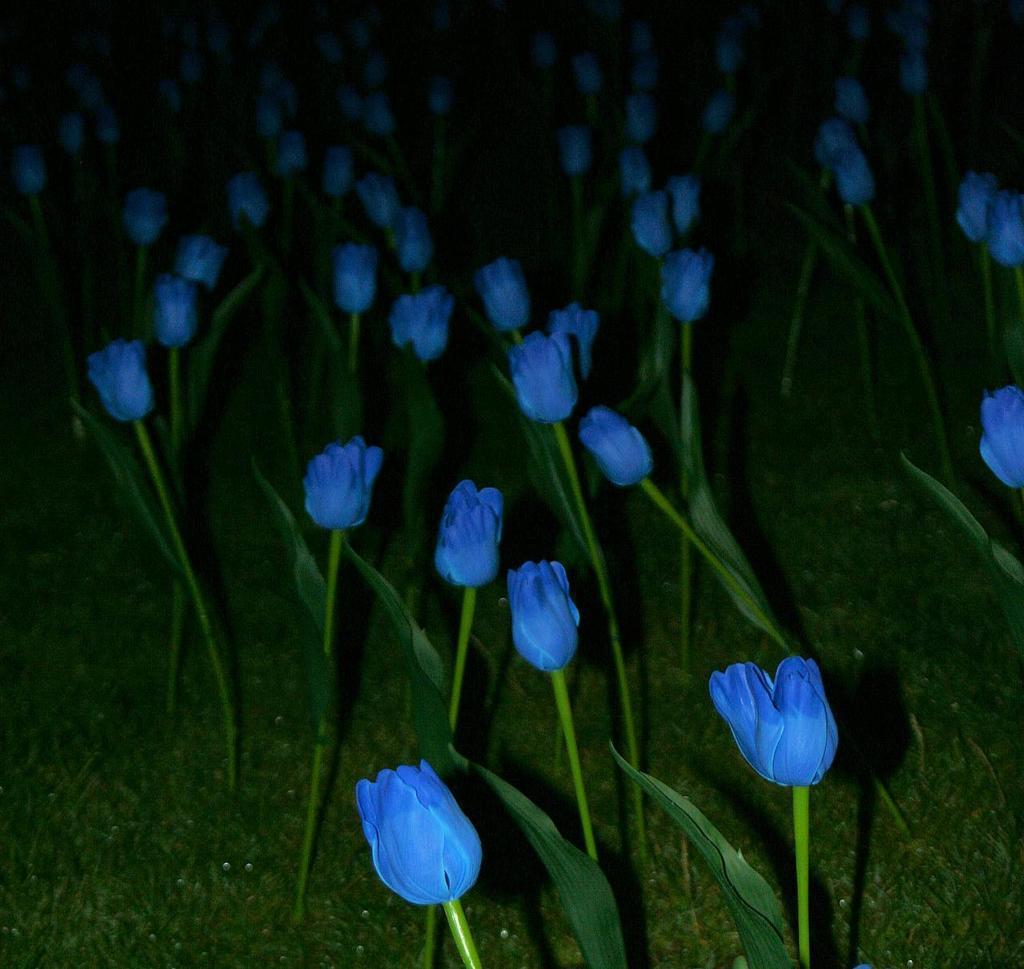Describe this image in one or two sentences. I think this picture is taken at night. On the ground there are tulip plants and flowers. The tulips are in blue in color. 